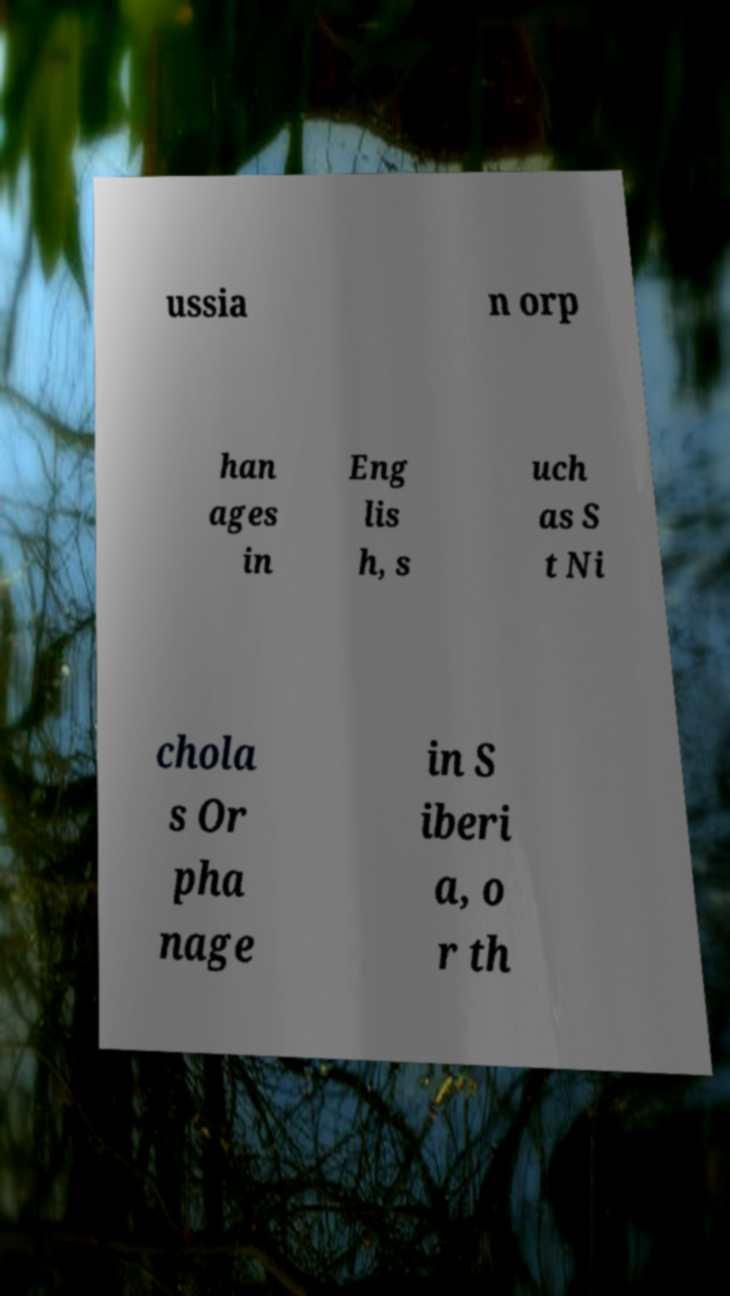Could you assist in decoding the text presented in this image and type it out clearly? ussia n orp han ages in Eng lis h, s uch as S t Ni chola s Or pha nage in S iberi a, o r th 